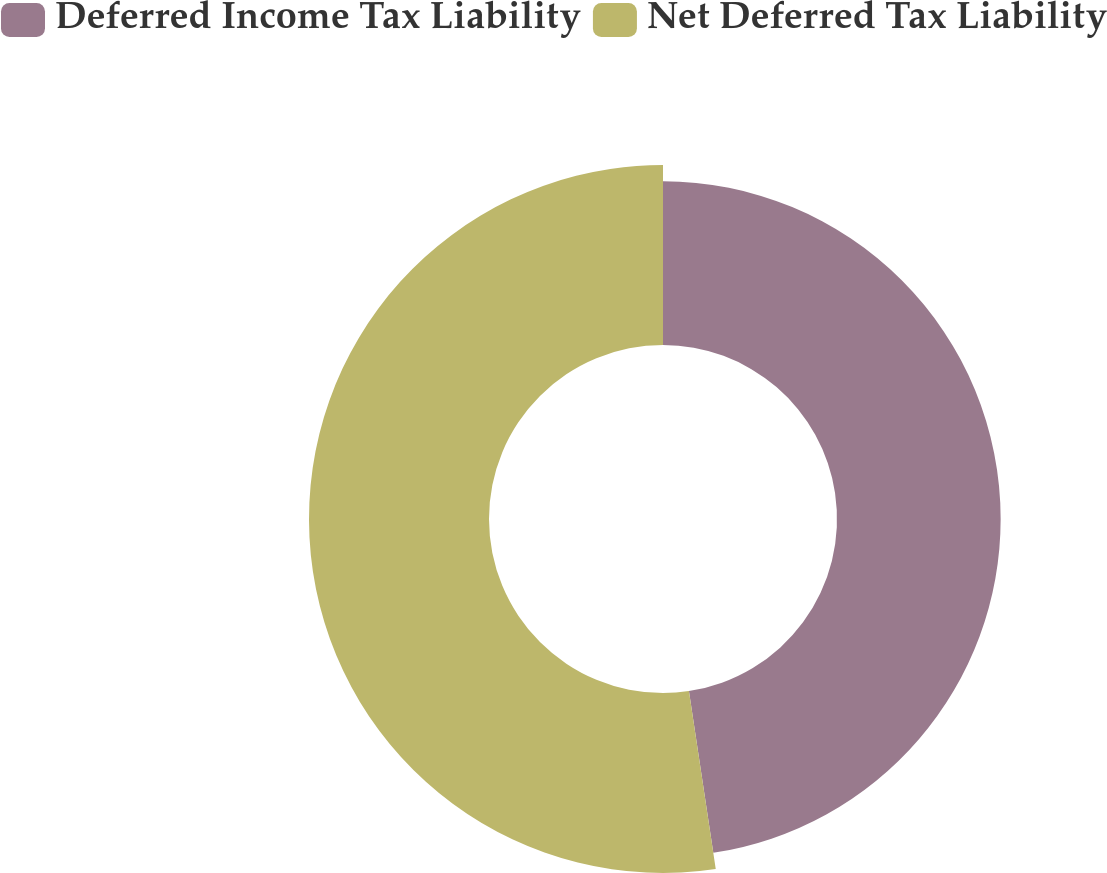Convert chart. <chart><loc_0><loc_0><loc_500><loc_500><pie_chart><fcel>Deferred Income Tax Liability<fcel>Net Deferred Tax Liability<nl><fcel>47.62%<fcel>52.38%<nl></chart> 